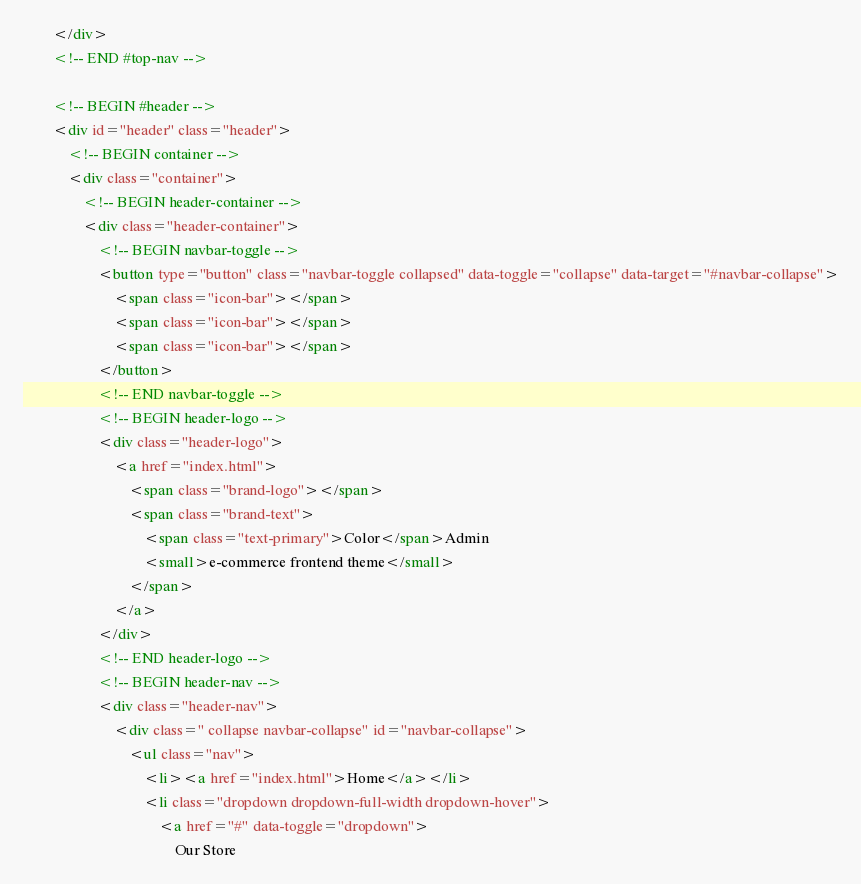Convert code to text. <code><loc_0><loc_0><loc_500><loc_500><_HTML_>		</div>
		<!-- END #top-nav -->
		
		<!-- BEGIN #header -->
		<div id="header" class="header">
			<!-- BEGIN container -->
			<div class="container">
				<!-- BEGIN header-container -->
				<div class="header-container">
					<!-- BEGIN navbar-toggle -->
					<button type="button" class="navbar-toggle collapsed" data-toggle="collapse" data-target="#navbar-collapse">
						<span class="icon-bar"></span>
						<span class="icon-bar"></span>
						<span class="icon-bar"></span>
					</button>
					<!-- END navbar-toggle -->
					<!-- BEGIN header-logo -->
					<div class="header-logo">
						<a href="index.html">
							<span class="brand-logo"></span>
							<span class="brand-text">
								<span class="text-primary">Color</span>Admin
								<small>e-commerce frontend theme</small>
							</span>
						</a>
					</div>
					<!-- END header-logo -->
					<!-- BEGIN header-nav -->
					<div class="header-nav">
						<div class=" collapse navbar-collapse" id="navbar-collapse">
							<ul class="nav">
								<li><a href="index.html">Home</a></li>
								<li class="dropdown dropdown-full-width dropdown-hover">
									<a href="#" data-toggle="dropdown">
										Our Store </code> 